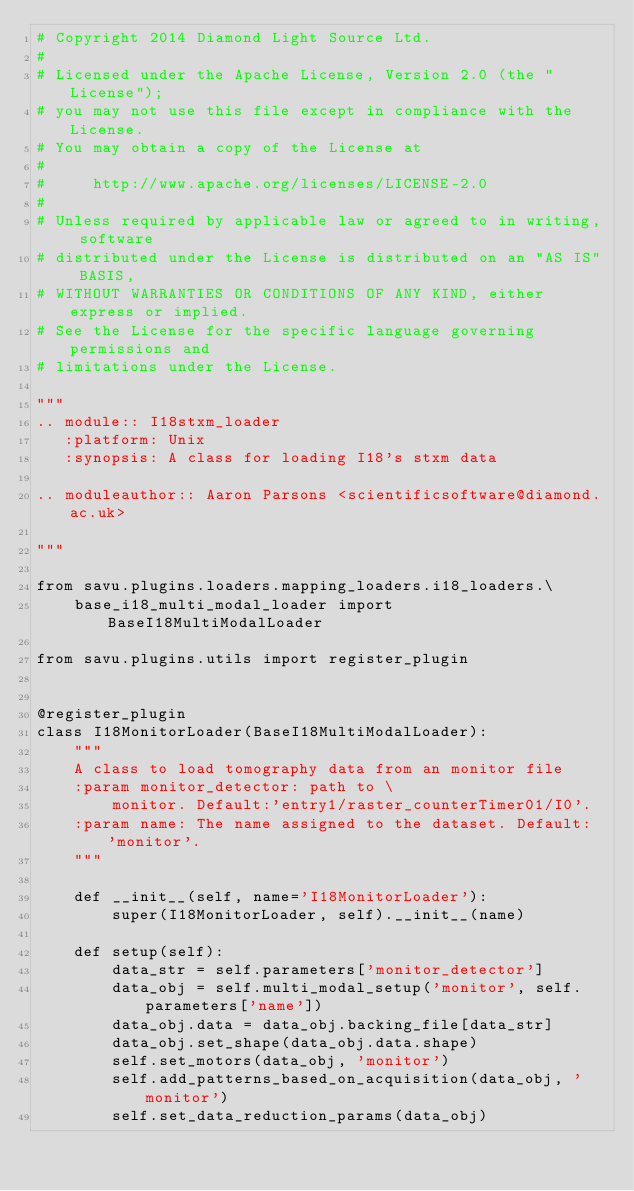Convert code to text. <code><loc_0><loc_0><loc_500><loc_500><_Python_># Copyright 2014 Diamond Light Source Ltd.
#
# Licensed under the Apache License, Version 2.0 (the "License");
# you may not use this file except in compliance with the License.
# You may obtain a copy of the License at
#
#     http://www.apache.org/licenses/LICENSE-2.0
#
# Unless required by applicable law or agreed to in writing, software
# distributed under the License is distributed on an "AS IS" BASIS,
# WITHOUT WARRANTIES OR CONDITIONS OF ANY KIND, either express or implied.
# See the License for the specific language governing permissions and
# limitations under the License.

"""
.. module:: I18stxm_loader
   :platform: Unix
   :synopsis: A class for loading I18's stxm data

.. moduleauthor:: Aaron Parsons <scientificsoftware@diamond.ac.uk>

"""

from savu.plugins.loaders.mapping_loaders.i18_loaders.\
    base_i18_multi_modal_loader import BaseI18MultiModalLoader

from savu.plugins.utils import register_plugin


@register_plugin
class I18MonitorLoader(BaseI18MultiModalLoader):
    """
    A class to load tomography data from an monitor file
    :param monitor_detector: path to \
        monitor. Default:'entry1/raster_counterTimer01/I0'.
    :param name: The name assigned to the dataset. Default: 'monitor'.
    """

    def __init__(self, name='I18MonitorLoader'):
        super(I18MonitorLoader, self).__init__(name)

    def setup(self):
        data_str = self.parameters['monitor_detector']
        data_obj = self.multi_modal_setup('monitor', self.parameters['name'])
        data_obj.data = data_obj.backing_file[data_str]
        data_obj.set_shape(data_obj.data.shape)
        self.set_motors(data_obj, 'monitor')
        self.add_patterns_based_on_acquisition(data_obj, 'monitor')
        self.set_data_reduction_params(data_obj)
</code> 